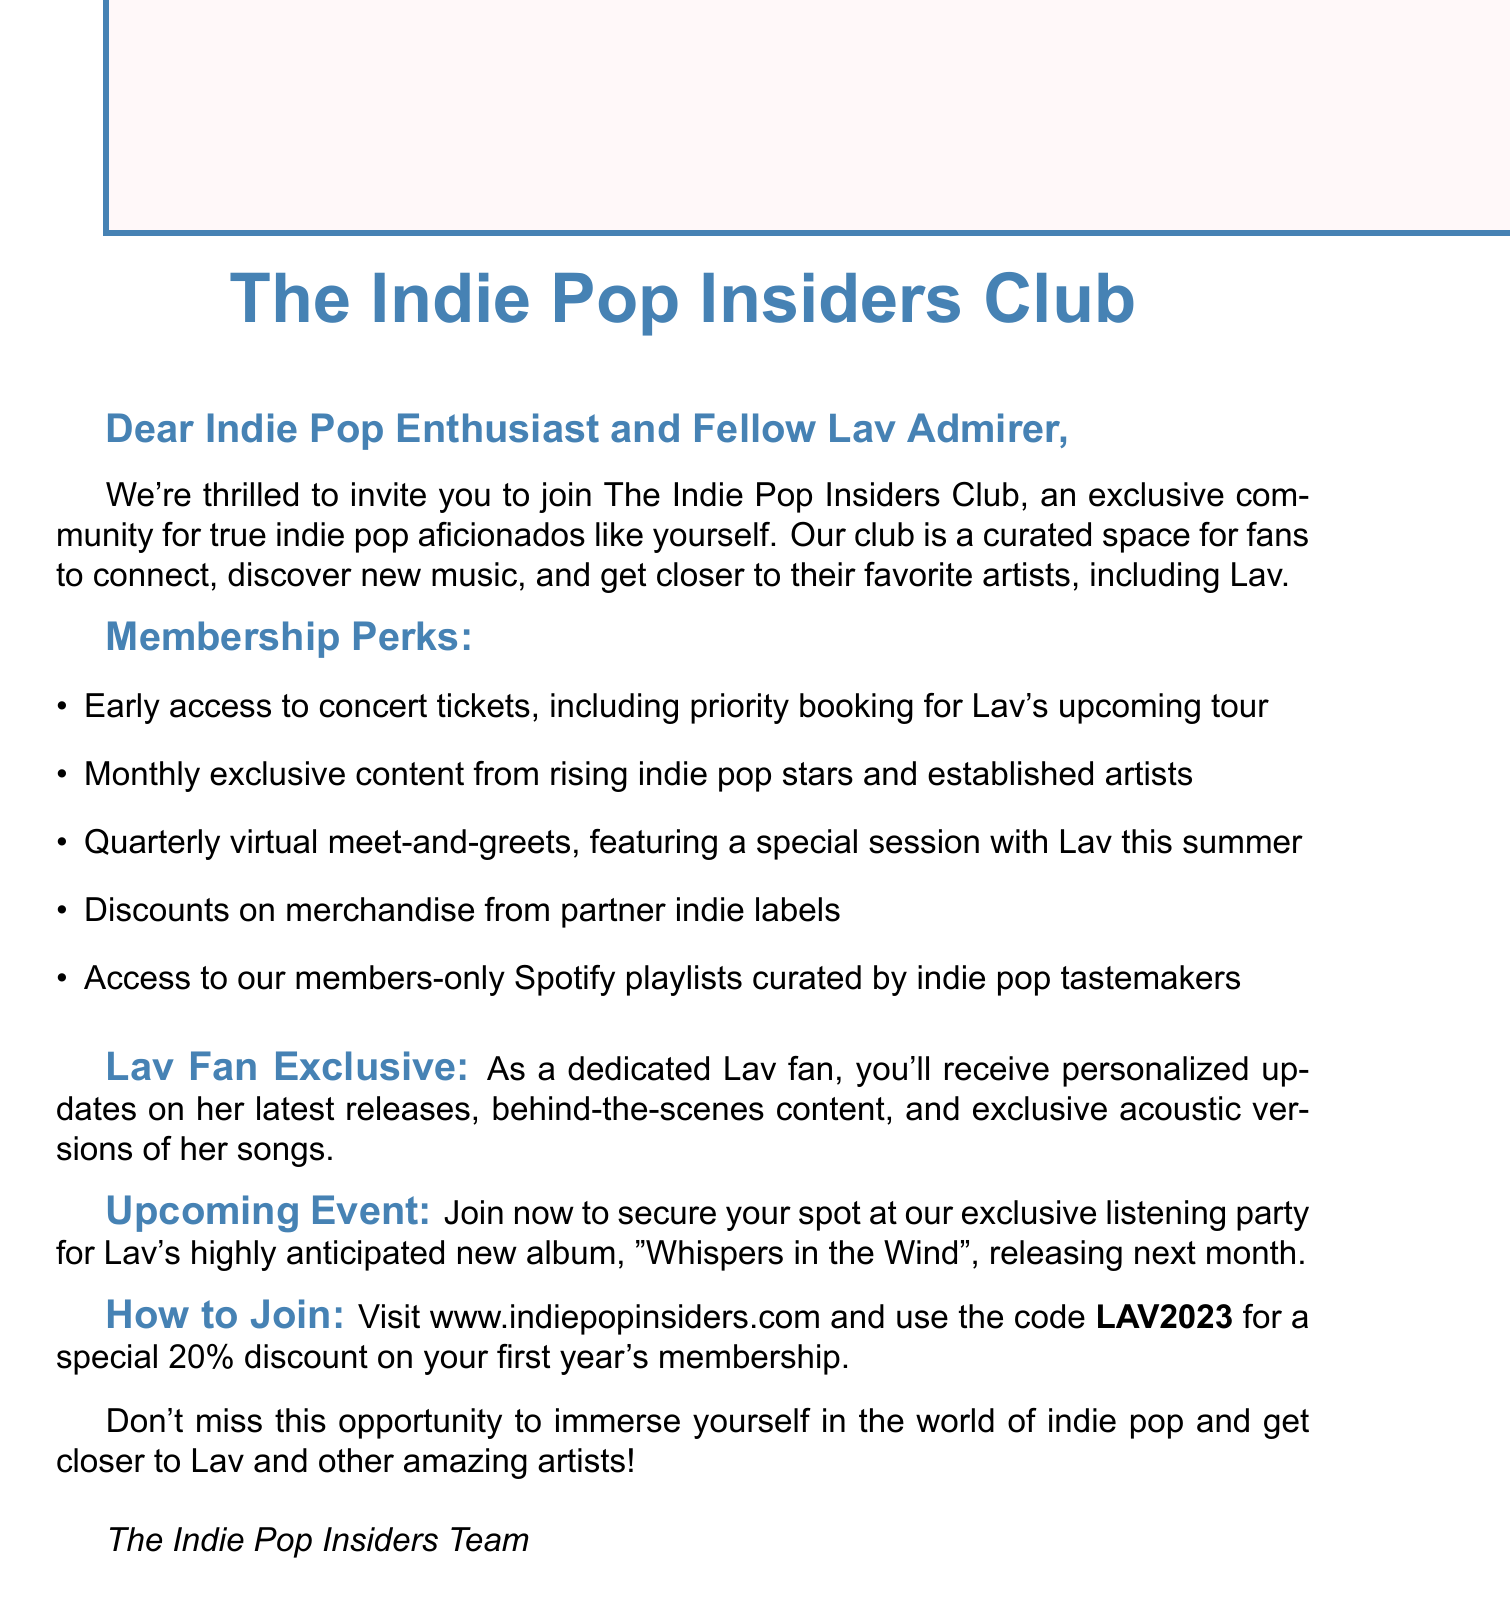What is the name of the fan club? The name of the fan club is mentioned in the document as The Indie Pop Insiders Club.
Answer: The Indie Pop Insiders Club Who is the target audience for the club? The document describes the club as a community for true indie pop aficionados.
Answer: Indie pop aficionados What special session will be held this summer? The document states there will be a special session with Lav during the quarterly virtual meet-and-greets.
Answer: Special session with Lav What discount code is provided for membership? The document includes a specific code for a membership discount.
Answer: LAV2023 What is the release date of Lav's new album? The document mentions that her new album is releasing next month, but does not specify the exact date.
Answer: Next month How often is exclusive content provided to members? The document specifies that exclusive content is delivered monthly.
Answer: Monthly What type of events does the club offer? The document states that there are quarterly virtual meet-and-greets with artists.
Answer: Quarterly virtual meet-and-greets What is the percentage discount for the first year's membership? The document states the discount for the first year's membership is 20%.
Answer: 20% Where can one join the fan club? The document provides a specific website where membership can be obtained.
Answer: www.indiepopinsiders.com 